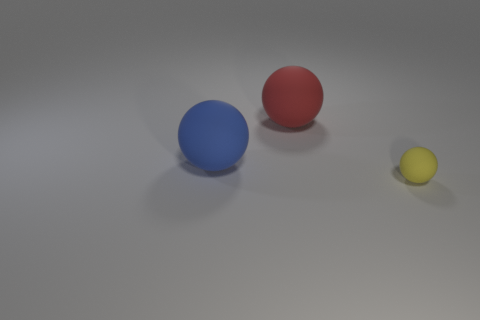Add 1 tiny purple cubes. How many objects exist? 4 Subtract 0 brown cylinders. How many objects are left? 3 Subtract all big red metal cylinders. Subtract all rubber spheres. How many objects are left? 0 Add 3 yellow things. How many yellow things are left? 4 Add 3 big red rubber spheres. How many big red rubber spheres exist? 4 